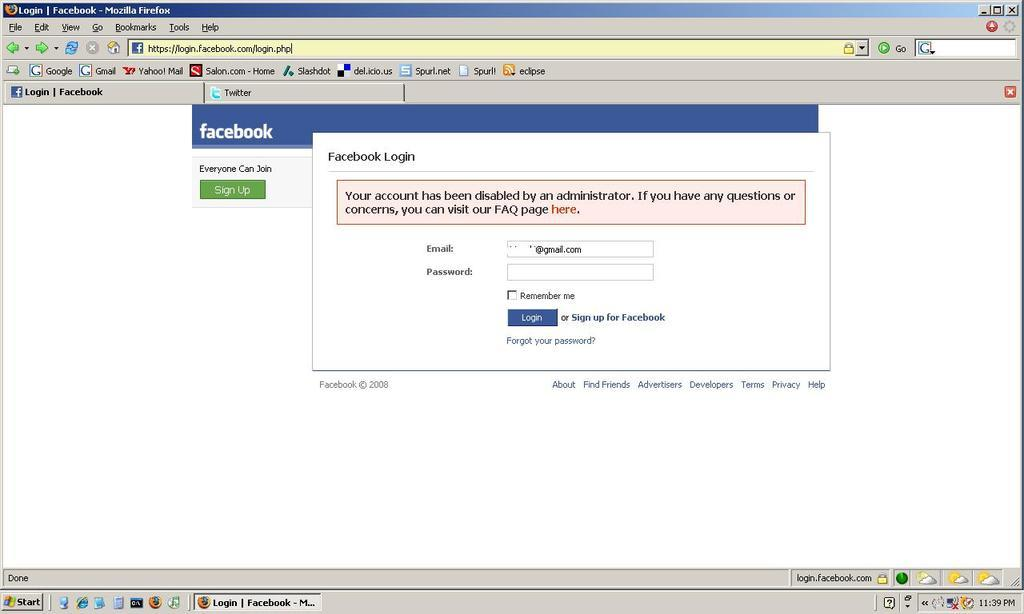Provide a one-sentence caption for the provided image. A screenshot of a Facebook login page that has a red error message saying 'your account has been disabled.'. 